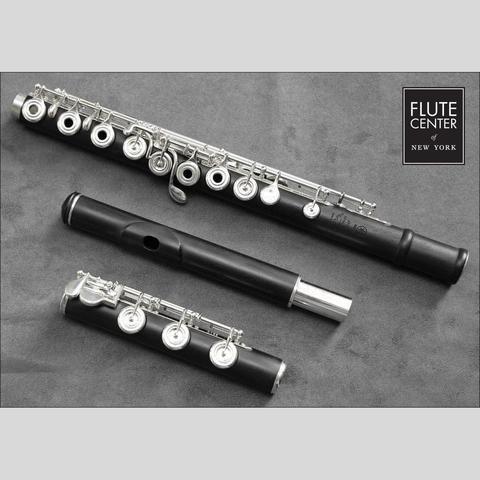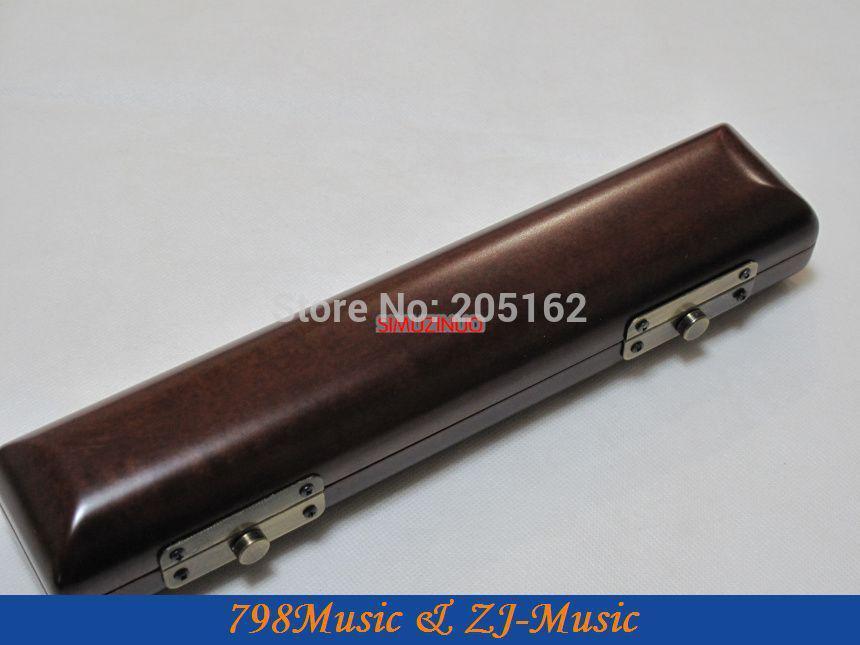The first image is the image on the left, the second image is the image on the right. Given the left and right images, does the statement "In at least one image there is a single close flute case sitting on the ground." hold true? Answer yes or no. Yes. The first image is the image on the left, the second image is the image on the right. For the images shown, is this caption "The combined images include one closed instrument case and three flute parts." true? Answer yes or no. Yes. 